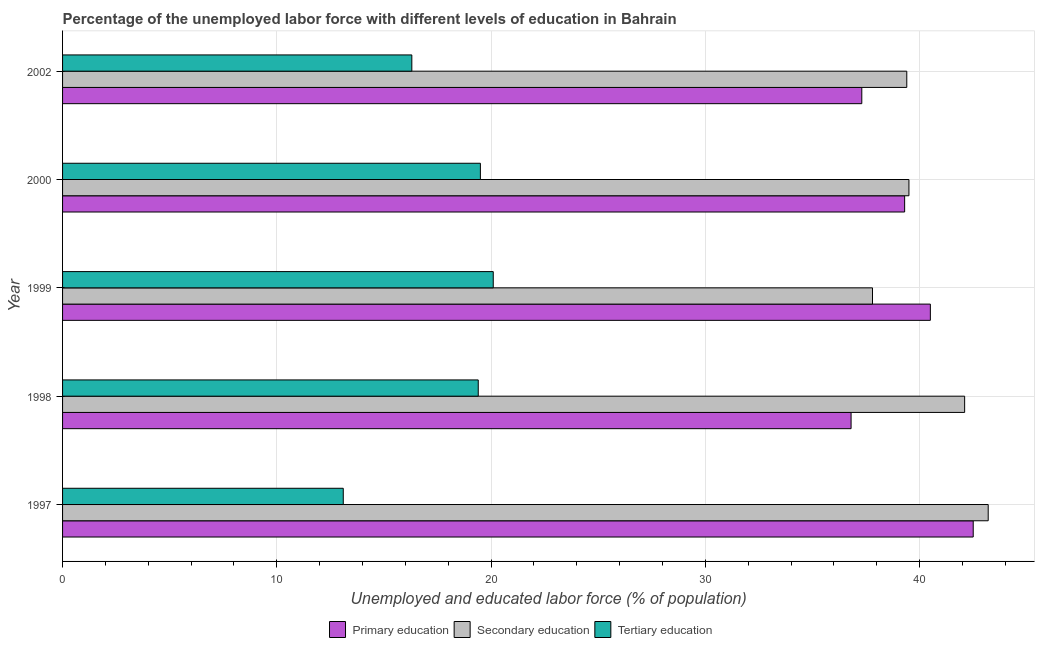How many groups of bars are there?
Offer a terse response. 5. Are the number of bars on each tick of the Y-axis equal?
Your answer should be compact. Yes. What is the label of the 2nd group of bars from the top?
Keep it short and to the point. 2000. In how many cases, is the number of bars for a given year not equal to the number of legend labels?
Make the answer very short. 0. What is the percentage of labor force who received tertiary education in 1997?
Your answer should be compact. 13.1. Across all years, what is the maximum percentage of labor force who received tertiary education?
Your answer should be compact. 20.1. Across all years, what is the minimum percentage of labor force who received secondary education?
Ensure brevity in your answer.  37.8. In which year was the percentage of labor force who received secondary education maximum?
Make the answer very short. 1997. What is the total percentage of labor force who received tertiary education in the graph?
Provide a succinct answer. 88.4. What is the difference between the percentage of labor force who received tertiary education in 1999 and that in 2000?
Your response must be concise. 0.6. What is the difference between the percentage of labor force who received secondary education in 2002 and the percentage of labor force who received primary education in 1999?
Make the answer very short. -1.1. What is the average percentage of labor force who received tertiary education per year?
Offer a very short reply. 17.68. In the year 2002, what is the difference between the percentage of labor force who received primary education and percentage of labor force who received secondary education?
Provide a short and direct response. -2.1. In how many years, is the percentage of labor force who received primary education greater than 18 %?
Your answer should be very brief. 5. What is the ratio of the percentage of labor force who received secondary education in 1997 to that in 1999?
Give a very brief answer. 1.14. Is the percentage of labor force who received tertiary education in 1997 less than that in 1998?
Your answer should be compact. Yes. What is the difference between the highest and the second highest percentage of labor force who received tertiary education?
Your answer should be compact. 0.6. What is the difference between the highest and the lowest percentage of labor force who received secondary education?
Your answer should be compact. 5.4. What does the 3rd bar from the top in 1997 represents?
Offer a very short reply. Primary education. What does the 2nd bar from the bottom in 2000 represents?
Keep it short and to the point. Secondary education. How many bars are there?
Provide a short and direct response. 15. What is the difference between two consecutive major ticks on the X-axis?
Give a very brief answer. 10. How are the legend labels stacked?
Ensure brevity in your answer.  Horizontal. What is the title of the graph?
Your answer should be compact. Percentage of the unemployed labor force with different levels of education in Bahrain. What is the label or title of the X-axis?
Provide a short and direct response. Unemployed and educated labor force (% of population). What is the Unemployed and educated labor force (% of population) of Primary education in 1997?
Provide a short and direct response. 42.5. What is the Unemployed and educated labor force (% of population) of Secondary education in 1997?
Provide a succinct answer. 43.2. What is the Unemployed and educated labor force (% of population) of Tertiary education in 1997?
Make the answer very short. 13.1. What is the Unemployed and educated labor force (% of population) of Primary education in 1998?
Offer a very short reply. 36.8. What is the Unemployed and educated labor force (% of population) of Secondary education in 1998?
Provide a succinct answer. 42.1. What is the Unemployed and educated labor force (% of population) of Tertiary education in 1998?
Your response must be concise. 19.4. What is the Unemployed and educated labor force (% of population) in Primary education in 1999?
Keep it short and to the point. 40.5. What is the Unemployed and educated labor force (% of population) in Secondary education in 1999?
Offer a terse response. 37.8. What is the Unemployed and educated labor force (% of population) of Tertiary education in 1999?
Provide a succinct answer. 20.1. What is the Unemployed and educated labor force (% of population) of Primary education in 2000?
Your answer should be very brief. 39.3. What is the Unemployed and educated labor force (% of population) in Secondary education in 2000?
Make the answer very short. 39.5. What is the Unemployed and educated labor force (% of population) of Tertiary education in 2000?
Give a very brief answer. 19.5. What is the Unemployed and educated labor force (% of population) in Primary education in 2002?
Your response must be concise. 37.3. What is the Unemployed and educated labor force (% of population) in Secondary education in 2002?
Provide a succinct answer. 39.4. What is the Unemployed and educated labor force (% of population) of Tertiary education in 2002?
Your answer should be compact. 16.3. Across all years, what is the maximum Unemployed and educated labor force (% of population) of Primary education?
Ensure brevity in your answer.  42.5. Across all years, what is the maximum Unemployed and educated labor force (% of population) of Secondary education?
Provide a short and direct response. 43.2. Across all years, what is the maximum Unemployed and educated labor force (% of population) in Tertiary education?
Ensure brevity in your answer.  20.1. Across all years, what is the minimum Unemployed and educated labor force (% of population) in Primary education?
Your answer should be very brief. 36.8. Across all years, what is the minimum Unemployed and educated labor force (% of population) in Secondary education?
Offer a very short reply. 37.8. Across all years, what is the minimum Unemployed and educated labor force (% of population) of Tertiary education?
Offer a very short reply. 13.1. What is the total Unemployed and educated labor force (% of population) of Primary education in the graph?
Keep it short and to the point. 196.4. What is the total Unemployed and educated labor force (% of population) of Secondary education in the graph?
Offer a terse response. 202. What is the total Unemployed and educated labor force (% of population) of Tertiary education in the graph?
Keep it short and to the point. 88.4. What is the difference between the Unemployed and educated labor force (% of population) of Primary education in 1997 and that in 1998?
Your answer should be compact. 5.7. What is the difference between the Unemployed and educated labor force (% of population) of Secondary education in 1997 and that in 1998?
Your response must be concise. 1.1. What is the difference between the Unemployed and educated labor force (% of population) of Primary education in 1997 and that in 1999?
Keep it short and to the point. 2. What is the difference between the Unemployed and educated labor force (% of population) of Secondary education in 1997 and that in 1999?
Give a very brief answer. 5.4. What is the difference between the Unemployed and educated labor force (% of population) of Primary education in 1997 and that in 2000?
Your answer should be very brief. 3.2. What is the difference between the Unemployed and educated labor force (% of population) of Tertiary education in 1997 and that in 2000?
Provide a short and direct response. -6.4. What is the difference between the Unemployed and educated labor force (% of population) in Primary education in 1997 and that in 2002?
Give a very brief answer. 5.2. What is the difference between the Unemployed and educated labor force (% of population) of Secondary education in 1998 and that in 1999?
Your answer should be very brief. 4.3. What is the difference between the Unemployed and educated labor force (% of population) in Tertiary education in 1998 and that in 2000?
Give a very brief answer. -0.1. What is the difference between the Unemployed and educated labor force (% of population) in Tertiary education in 1998 and that in 2002?
Keep it short and to the point. 3.1. What is the difference between the Unemployed and educated labor force (% of population) in Primary education in 1999 and that in 2000?
Provide a short and direct response. 1.2. What is the difference between the Unemployed and educated labor force (% of population) in Secondary education in 1999 and that in 2000?
Make the answer very short. -1.7. What is the difference between the Unemployed and educated labor force (% of population) in Secondary education in 1999 and that in 2002?
Offer a terse response. -1.6. What is the difference between the Unemployed and educated labor force (% of population) in Primary education in 2000 and that in 2002?
Offer a terse response. 2. What is the difference between the Unemployed and educated labor force (% of population) of Secondary education in 2000 and that in 2002?
Ensure brevity in your answer.  0.1. What is the difference between the Unemployed and educated labor force (% of population) in Primary education in 1997 and the Unemployed and educated labor force (% of population) in Secondary education in 1998?
Provide a short and direct response. 0.4. What is the difference between the Unemployed and educated labor force (% of population) of Primary education in 1997 and the Unemployed and educated labor force (% of population) of Tertiary education in 1998?
Make the answer very short. 23.1. What is the difference between the Unemployed and educated labor force (% of population) in Secondary education in 1997 and the Unemployed and educated labor force (% of population) in Tertiary education in 1998?
Offer a very short reply. 23.8. What is the difference between the Unemployed and educated labor force (% of population) in Primary education in 1997 and the Unemployed and educated labor force (% of population) in Tertiary education in 1999?
Your answer should be very brief. 22.4. What is the difference between the Unemployed and educated labor force (% of population) in Secondary education in 1997 and the Unemployed and educated labor force (% of population) in Tertiary education in 1999?
Give a very brief answer. 23.1. What is the difference between the Unemployed and educated labor force (% of population) in Primary education in 1997 and the Unemployed and educated labor force (% of population) in Secondary education in 2000?
Your answer should be very brief. 3. What is the difference between the Unemployed and educated labor force (% of population) in Secondary education in 1997 and the Unemployed and educated labor force (% of population) in Tertiary education in 2000?
Your answer should be very brief. 23.7. What is the difference between the Unemployed and educated labor force (% of population) of Primary education in 1997 and the Unemployed and educated labor force (% of population) of Tertiary education in 2002?
Give a very brief answer. 26.2. What is the difference between the Unemployed and educated labor force (% of population) in Secondary education in 1997 and the Unemployed and educated labor force (% of population) in Tertiary education in 2002?
Your answer should be compact. 26.9. What is the difference between the Unemployed and educated labor force (% of population) in Primary education in 1998 and the Unemployed and educated labor force (% of population) in Secondary education in 1999?
Provide a succinct answer. -1. What is the difference between the Unemployed and educated labor force (% of population) in Secondary education in 1998 and the Unemployed and educated labor force (% of population) in Tertiary education in 1999?
Provide a succinct answer. 22. What is the difference between the Unemployed and educated labor force (% of population) of Secondary education in 1998 and the Unemployed and educated labor force (% of population) of Tertiary education in 2000?
Make the answer very short. 22.6. What is the difference between the Unemployed and educated labor force (% of population) of Primary education in 1998 and the Unemployed and educated labor force (% of population) of Secondary education in 2002?
Ensure brevity in your answer.  -2.6. What is the difference between the Unemployed and educated labor force (% of population) in Primary education in 1998 and the Unemployed and educated labor force (% of population) in Tertiary education in 2002?
Ensure brevity in your answer.  20.5. What is the difference between the Unemployed and educated labor force (% of population) of Secondary education in 1998 and the Unemployed and educated labor force (% of population) of Tertiary education in 2002?
Keep it short and to the point. 25.8. What is the difference between the Unemployed and educated labor force (% of population) of Primary education in 1999 and the Unemployed and educated labor force (% of population) of Tertiary education in 2000?
Provide a short and direct response. 21. What is the difference between the Unemployed and educated labor force (% of population) in Primary education in 1999 and the Unemployed and educated labor force (% of population) in Secondary education in 2002?
Provide a succinct answer. 1.1. What is the difference between the Unemployed and educated labor force (% of population) of Primary education in 1999 and the Unemployed and educated labor force (% of population) of Tertiary education in 2002?
Ensure brevity in your answer.  24.2. What is the difference between the Unemployed and educated labor force (% of population) of Primary education in 2000 and the Unemployed and educated labor force (% of population) of Tertiary education in 2002?
Keep it short and to the point. 23. What is the difference between the Unemployed and educated labor force (% of population) of Secondary education in 2000 and the Unemployed and educated labor force (% of population) of Tertiary education in 2002?
Make the answer very short. 23.2. What is the average Unemployed and educated labor force (% of population) of Primary education per year?
Your response must be concise. 39.28. What is the average Unemployed and educated labor force (% of population) of Secondary education per year?
Ensure brevity in your answer.  40.4. What is the average Unemployed and educated labor force (% of population) in Tertiary education per year?
Make the answer very short. 17.68. In the year 1997, what is the difference between the Unemployed and educated labor force (% of population) of Primary education and Unemployed and educated labor force (% of population) of Secondary education?
Ensure brevity in your answer.  -0.7. In the year 1997, what is the difference between the Unemployed and educated labor force (% of population) in Primary education and Unemployed and educated labor force (% of population) in Tertiary education?
Provide a succinct answer. 29.4. In the year 1997, what is the difference between the Unemployed and educated labor force (% of population) of Secondary education and Unemployed and educated labor force (% of population) of Tertiary education?
Provide a short and direct response. 30.1. In the year 1998, what is the difference between the Unemployed and educated labor force (% of population) of Secondary education and Unemployed and educated labor force (% of population) of Tertiary education?
Ensure brevity in your answer.  22.7. In the year 1999, what is the difference between the Unemployed and educated labor force (% of population) in Primary education and Unemployed and educated labor force (% of population) in Secondary education?
Your response must be concise. 2.7. In the year 1999, what is the difference between the Unemployed and educated labor force (% of population) of Primary education and Unemployed and educated labor force (% of population) of Tertiary education?
Offer a terse response. 20.4. In the year 2000, what is the difference between the Unemployed and educated labor force (% of population) in Primary education and Unemployed and educated labor force (% of population) in Secondary education?
Your response must be concise. -0.2. In the year 2000, what is the difference between the Unemployed and educated labor force (% of population) in Primary education and Unemployed and educated labor force (% of population) in Tertiary education?
Give a very brief answer. 19.8. In the year 2002, what is the difference between the Unemployed and educated labor force (% of population) of Secondary education and Unemployed and educated labor force (% of population) of Tertiary education?
Your response must be concise. 23.1. What is the ratio of the Unemployed and educated labor force (% of population) in Primary education in 1997 to that in 1998?
Your answer should be compact. 1.15. What is the ratio of the Unemployed and educated labor force (% of population) in Secondary education in 1997 to that in 1998?
Offer a very short reply. 1.03. What is the ratio of the Unemployed and educated labor force (% of population) in Tertiary education in 1997 to that in 1998?
Make the answer very short. 0.68. What is the ratio of the Unemployed and educated labor force (% of population) of Primary education in 1997 to that in 1999?
Provide a succinct answer. 1.05. What is the ratio of the Unemployed and educated labor force (% of population) of Secondary education in 1997 to that in 1999?
Your response must be concise. 1.14. What is the ratio of the Unemployed and educated labor force (% of population) in Tertiary education in 1997 to that in 1999?
Keep it short and to the point. 0.65. What is the ratio of the Unemployed and educated labor force (% of population) of Primary education in 1997 to that in 2000?
Your response must be concise. 1.08. What is the ratio of the Unemployed and educated labor force (% of population) in Secondary education in 1997 to that in 2000?
Your answer should be compact. 1.09. What is the ratio of the Unemployed and educated labor force (% of population) of Tertiary education in 1997 to that in 2000?
Your answer should be compact. 0.67. What is the ratio of the Unemployed and educated labor force (% of population) of Primary education in 1997 to that in 2002?
Give a very brief answer. 1.14. What is the ratio of the Unemployed and educated labor force (% of population) of Secondary education in 1997 to that in 2002?
Give a very brief answer. 1.1. What is the ratio of the Unemployed and educated labor force (% of population) of Tertiary education in 1997 to that in 2002?
Your answer should be compact. 0.8. What is the ratio of the Unemployed and educated labor force (% of population) of Primary education in 1998 to that in 1999?
Offer a terse response. 0.91. What is the ratio of the Unemployed and educated labor force (% of population) of Secondary education in 1998 to that in 1999?
Make the answer very short. 1.11. What is the ratio of the Unemployed and educated labor force (% of population) of Tertiary education in 1998 to that in 1999?
Provide a short and direct response. 0.97. What is the ratio of the Unemployed and educated labor force (% of population) of Primary education in 1998 to that in 2000?
Provide a short and direct response. 0.94. What is the ratio of the Unemployed and educated labor force (% of population) in Secondary education in 1998 to that in 2000?
Offer a terse response. 1.07. What is the ratio of the Unemployed and educated labor force (% of population) of Primary education in 1998 to that in 2002?
Keep it short and to the point. 0.99. What is the ratio of the Unemployed and educated labor force (% of population) in Secondary education in 1998 to that in 2002?
Give a very brief answer. 1.07. What is the ratio of the Unemployed and educated labor force (% of population) of Tertiary education in 1998 to that in 2002?
Offer a terse response. 1.19. What is the ratio of the Unemployed and educated labor force (% of population) in Primary education in 1999 to that in 2000?
Your answer should be very brief. 1.03. What is the ratio of the Unemployed and educated labor force (% of population) of Secondary education in 1999 to that in 2000?
Ensure brevity in your answer.  0.96. What is the ratio of the Unemployed and educated labor force (% of population) of Tertiary education in 1999 to that in 2000?
Offer a very short reply. 1.03. What is the ratio of the Unemployed and educated labor force (% of population) in Primary education in 1999 to that in 2002?
Give a very brief answer. 1.09. What is the ratio of the Unemployed and educated labor force (% of population) in Secondary education in 1999 to that in 2002?
Your response must be concise. 0.96. What is the ratio of the Unemployed and educated labor force (% of population) in Tertiary education in 1999 to that in 2002?
Your answer should be very brief. 1.23. What is the ratio of the Unemployed and educated labor force (% of population) in Primary education in 2000 to that in 2002?
Ensure brevity in your answer.  1.05. What is the ratio of the Unemployed and educated labor force (% of population) in Secondary education in 2000 to that in 2002?
Make the answer very short. 1. What is the ratio of the Unemployed and educated labor force (% of population) of Tertiary education in 2000 to that in 2002?
Provide a short and direct response. 1.2. What is the difference between the highest and the second highest Unemployed and educated labor force (% of population) in Secondary education?
Offer a very short reply. 1.1. What is the difference between the highest and the second highest Unemployed and educated labor force (% of population) in Tertiary education?
Make the answer very short. 0.6. What is the difference between the highest and the lowest Unemployed and educated labor force (% of population) of Primary education?
Make the answer very short. 5.7. What is the difference between the highest and the lowest Unemployed and educated labor force (% of population) of Secondary education?
Provide a short and direct response. 5.4. What is the difference between the highest and the lowest Unemployed and educated labor force (% of population) in Tertiary education?
Offer a terse response. 7. 